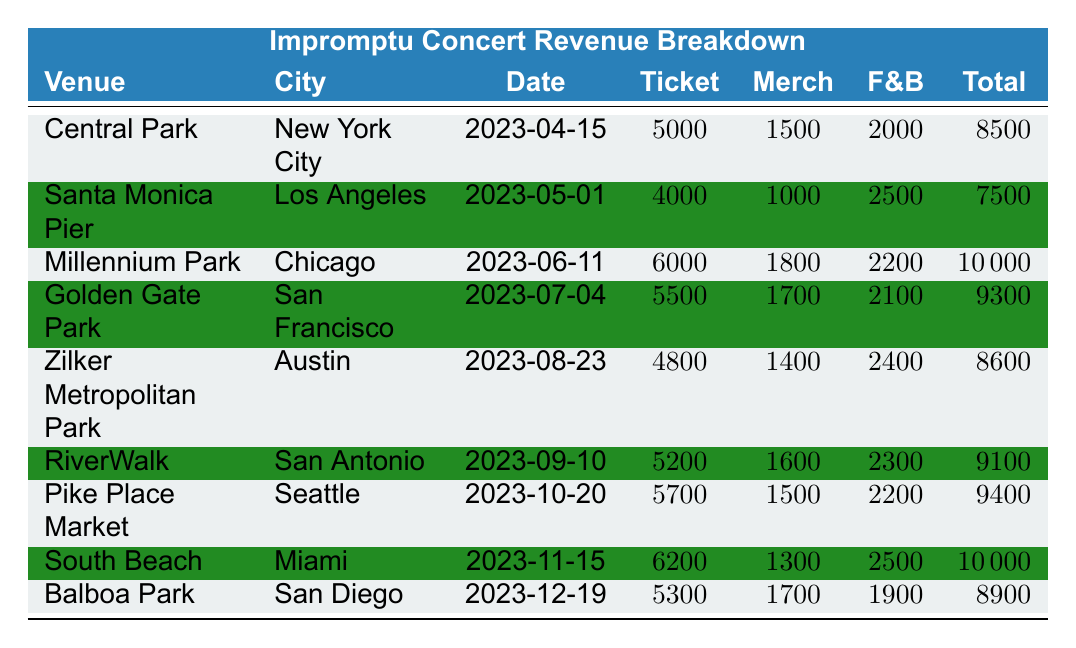What's the total revenue generated from concerts held in New York City? The table shows that only one concert was held in New York City at Central Park, which generated a total revenue of 8500.
Answer: 8500 What was the merchandise sales revenue for the concert at Santa Monica Pier? The revenue for merchandise sales at Santa Monica Pier is listed in the table as 1000.
Answer: 1000 Which venue had the highest ticket revenue, and what was the amount? By comparing the ticket revenues from all venues, Millennium Park had the highest ticket revenue at 6000.
Answer: Millennium Park, 6000 What was the average food and beverage sales across all venues? To find the average, sum the food and beverage sales: (2000 + 2500 + 2200 + 2100 + 2400 + 2300 + 2200 + 2500 + 1900) = 20100. There are 9 venues, so the average is 20100 / 9 = 2233.33, rounding to 2233.
Answer: 2233 Did any venue generate total revenue below 8000? By reviewing the total revenues for all venues, Santa Monica Pier is the only venue that generated a total revenue of 7500, which is below 8000.
Answer: Yes What is the total merchandise sales revenue for concerts in Texas? The concerts in Texas were held at two venues: Zilker Metropolitan Park and RiverWalk. Their merchandise sales are 1400 and 1600, respectively. The total is 1400 + 1600 = 3000.
Answer: 3000 Which city, among those listed, had the concert with the earliest event date? The earliest concert date is listed as April 15, 2023, which was held in New York City.
Answer: New York City How does the total revenue from concerts in Chicago compare to the total revenue in Miami? Chicago had a total revenue of 10000, while Miami also had a total revenue of 10000. Since both amounts are equal, they are the same.
Answer: They are the same 